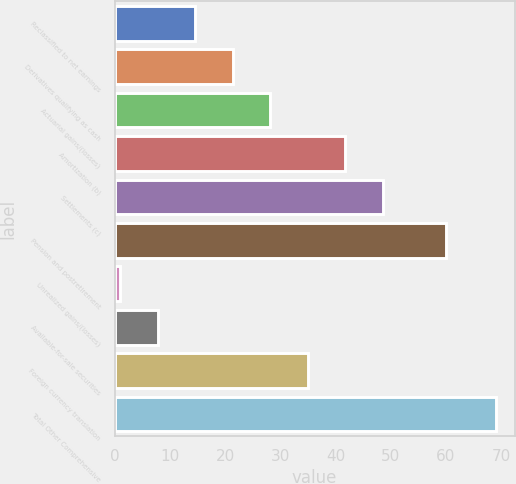Convert chart to OTSL. <chart><loc_0><loc_0><loc_500><loc_500><bar_chart><fcel>Reclassified to net earnings<fcel>Derivatives qualifying as cash<fcel>Actuarial gains/(losses)<fcel>Amortization (b)<fcel>Settlements (c)<fcel>Pension and postretirement<fcel>Unrealized gains/(losses)<fcel>Available-for-sale securities<fcel>Foreign currency translation<fcel>Total Other Comprehensive<nl><fcel>14.6<fcel>21.4<fcel>28.2<fcel>41.8<fcel>48.6<fcel>60<fcel>1<fcel>7.8<fcel>35<fcel>69<nl></chart> 